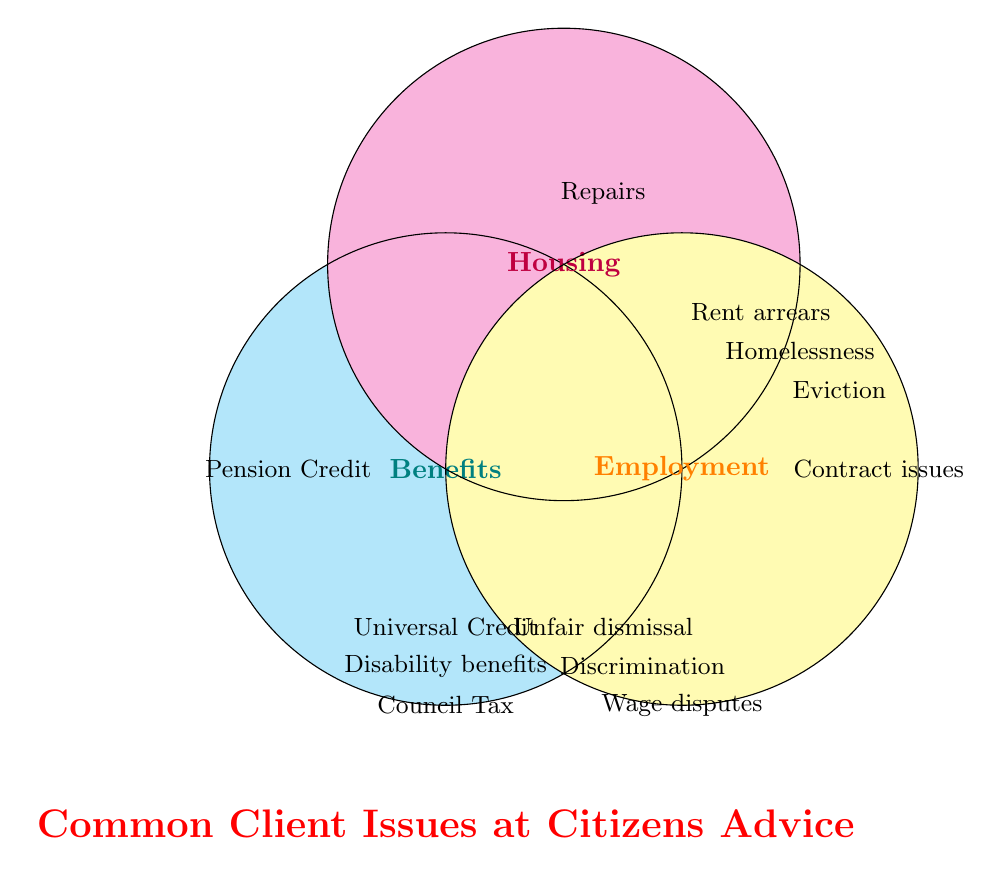What are the three categories represented in the Venn Diagram? The Venn Diagram shows circles each labeled with a category. These categories are "Benefits," "Housing," and "Employment."
Answer: Benefits, Housing, Employment What issues fall under the 'Housing' category? The issues are listed within the circle labeled "Housing." According to the diagram, the issues are "Rent arrears," "Homelessness," "Eviction," and "Repairs."
Answer: Rent arrears, Homelessness, Eviction, Repairs Which category includes "Council Tax" as an issue? "Council Tax" is positioned within the circle labeled "Benefits."
Answer: Benefits What is the title of the Venn Diagram? The bold text below the diagram indicates the title, which is "Common Client Issues at Citizens Advice."
Answer: Common Client Issues at Citizens Advice Where is "Universal Credit" located in the diagram? "Universal Credit" is located within the circle labeled "Benefits."
Answer: Benefits How many issues are listed under 'Employment'? The issues under "Employment" can be counted within the circle labeled "Employment." There are four issues: "Unfair dismissal," "Discrimination," "Wage disputes," and "Contract issues."
Answer: Four Which issue is common to all three categories? By examining the intersections in the Venn Diagram, none of the issues overlap across all three categories.
Answer: None What category is 'Homelessness' associated with? The issue "Homelessness" is located within the circle labeled "Housing."
Answer: Housing What color represents the 'Employment' category? The circle labeled "Employment" is colored orange.
Answer: Orange Is "Pension Credit" related to 'Housing' or 'Employment'? "Pension Credit" is found within the circle labeled "Benefits," not 'Housing' or 'Employment.'
Answer: No 